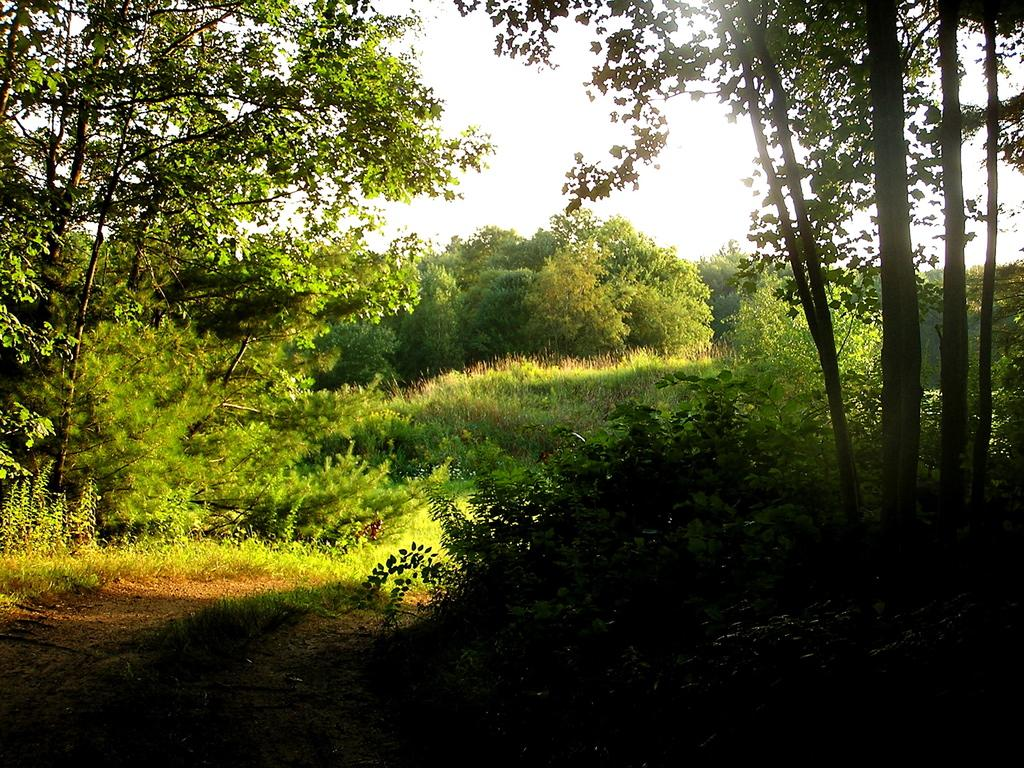What can be seen in the image that people might walk on? There is a path in the image that people might walk on. What type of vegetation is present in the image? There are trees in the image. What is visible behind the trees in the image? The sky is visible behind the trees in the image. Can you tell me how many people are talking to the trees in the image? There are no people talking to the trees in the image; it only shows a path, trees, and the sky. Is there a mitten hanging on one of the trees in the image? There is no mitten present in the image; it only shows a path, trees, and the sky. 